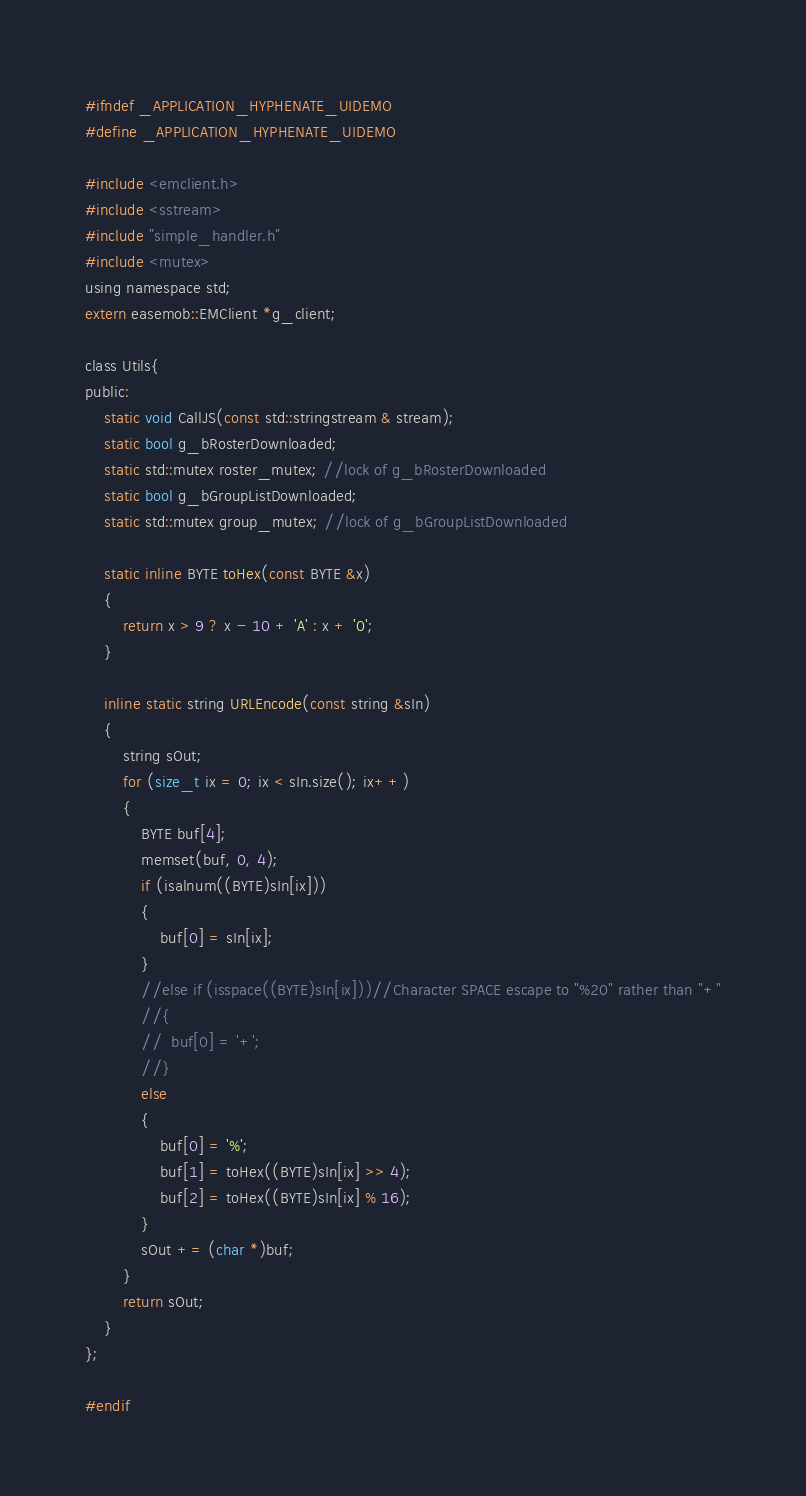Convert code to text. <code><loc_0><loc_0><loc_500><loc_500><_C_>#ifndef _APPLICATION_HYPHENATE_UIDEMO
#define _APPLICATION_HYPHENATE_UIDEMO

#include <emclient.h>
#include <sstream>
#include "simple_handler.h"
#include <mutex>
using namespace std;
extern easemob::EMClient *g_client;

class Utils{
public:
	static void CallJS(const std::stringstream & stream);
	static bool g_bRosterDownloaded;
	static std::mutex roster_mutex; //lock of g_bRosterDownloaded
	static bool g_bGroupListDownloaded;
	static std::mutex group_mutex; //lock of g_bGroupListDownloaded

	static inline BYTE toHex(const BYTE &x)
	{
		return x > 9 ? x - 10 + 'A' : x + '0';
	}

	inline static string URLEncode(const string &sIn)
	{
		string sOut;
		for (size_t ix = 0; ix < sIn.size(); ix++)
		{
			BYTE buf[4];
			memset(buf, 0, 4);
			if (isalnum((BYTE)sIn[ix]))
			{
				buf[0] = sIn[ix];
			}
			//else if (isspace((BYTE)sIn[ix]))//Character SPACE escape to "%20" rather than "+"
			//{
			//	buf[0] = '+';
			//}
			else
			{
				buf[0] = '%';
				buf[1] = toHex((BYTE)sIn[ix] >> 4);
				buf[2] = toHex((BYTE)sIn[ix] % 16);
			}
			sOut += (char *)buf;
		}
		return sOut;
	}
};

#endif</code> 